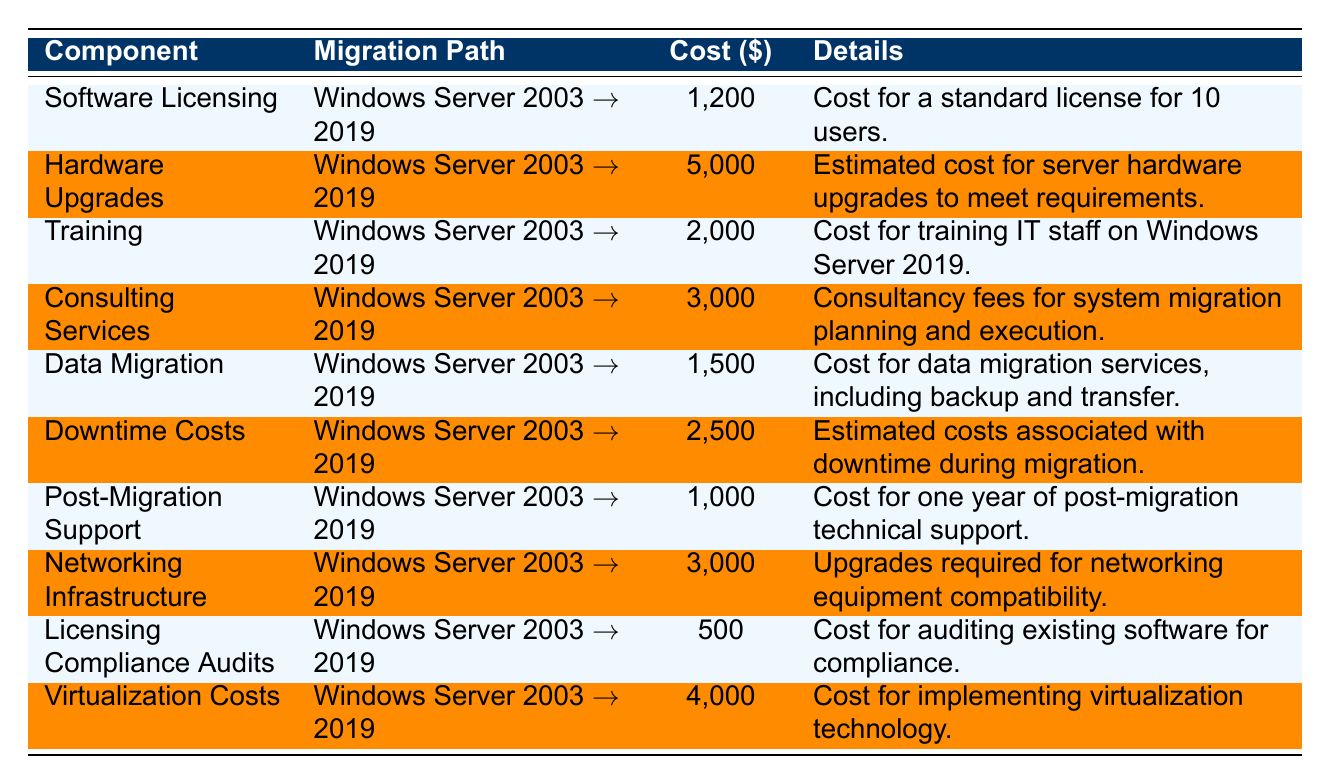What is the total cost for Software Licensing? The cost for Software Licensing is listed as 1200 in the table.
Answer: 1200 How much do Hardware Upgrades cost? The cost for Hardware Upgrades is listed as 5000 in the table.
Answer: 5000 What is the combined cost of Training and Post-Migration Support? The cost for Training is 2000 and the cost for Post-Migration Support is 1000. Adding these values gives 2000 + 1000 = 3000.
Answer: 3000 Is the cost for Data Migration greater than the cost for Licensing Compliance Audits? The cost for Data Migration is 1500 and the cost for Licensing Compliance Audits is 500. Since 1500 is greater than 500, the answer is yes.
Answer: Yes What is the average cost of the components related to migration? We sum all costs: 1200 + 5000 + 2000 + 3000 + 1500 + 2500 + 1000 + 3000 + 500 + 4000 = 19100. There are 10 components, so the average is 19100 / 10 = 1910.
Answer: 1910 What is the cost difference between Virtualization Costs and Downtime Costs? The cost for Virtualization Costs is 4000 and the cost for Downtime Costs is 2500. The difference is 4000 - 2500 = 1500.
Answer: 1500 Is the cost for Consulting Services less than or equal to the cost for Hardware Upgrades? The cost for Consulting Services is 3000 and the cost for Hardware Upgrades is 5000. Since 3000 is less than 5000, the answer is yes.
Answer: Yes What components have costs above 2000? The components that are above 2000 are Hardware Upgrades (5000), Training (2000), Consulting Services (3000), and Networking Infrastructure (3000).
Answer: Hardware Upgrades, Training, Consulting Services, Networking Infrastructure What is the total estimated cost of migration including all components? To find the total estimated cost, we sum all listed costs: 1200 + 5000 + 2000 + 3000 + 1500 + 2500 + 1000 + 3000 + 500 + 4000 = 19100.
Answer: 19100 